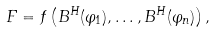Convert formula to latex. <formula><loc_0><loc_0><loc_500><loc_500>F = f \left ( B ^ { H } ( \varphi _ { 1 } ) , \dots , B ^ { H } ( \varphi _ { n } ) \right ) ,</formula> 